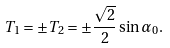<formula> <loc_0><loc_0><loc_500><loc_500>T _ { 1 } = \pm T _ { 2 } = \pm \frac { \sqrt { 2 } } { 2 } \sin \alpha _ { 0 } .</formula> 